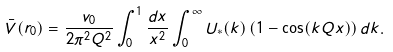Convert formula to latex. <formula><loc_0><loc_0><loc_500><loc_500>\bar { V } ( { r } _ { 0 } ) = \frac { v _ { 0 } } { 2 \pi ^ { 2 } Q ^ { 2 } } \int _ { 0 } ^ { 1 } \frac { d x } { x ^ { 2 } } \int _ { 0 } ^ { \infty } U _ { \ast } ( k ) \left ( 1 - \cos ( k Q x ) \right ) d k .</formula> 